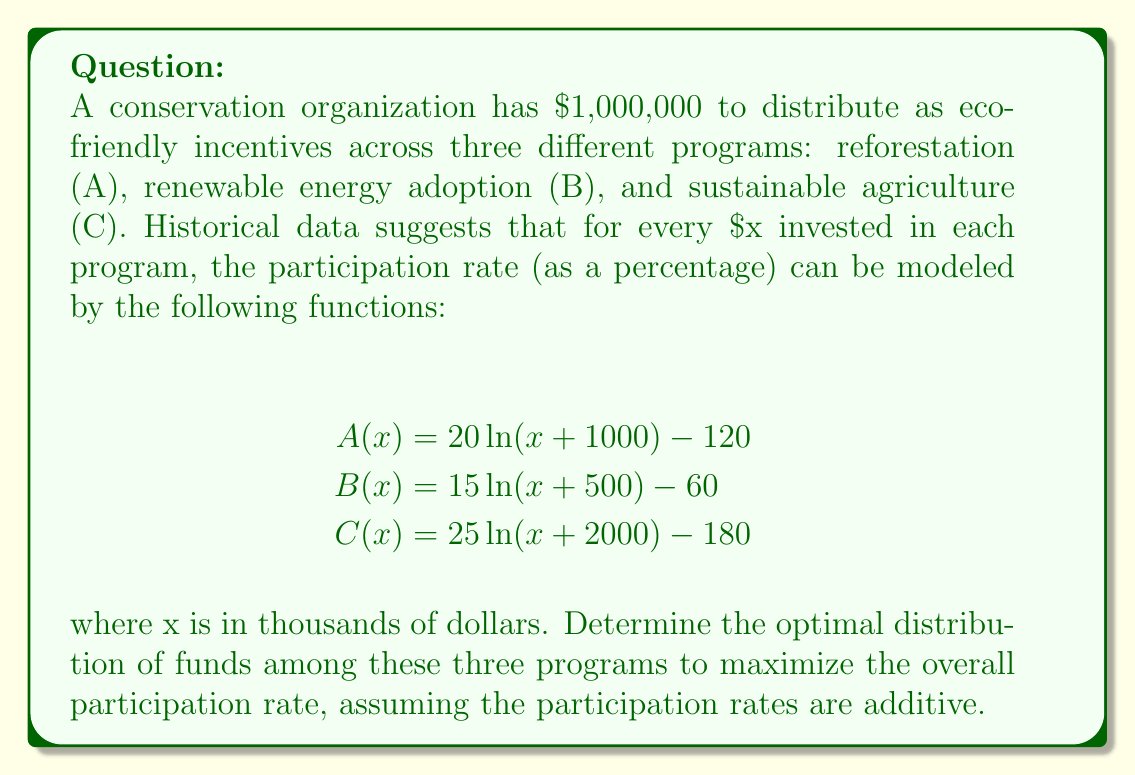What is the answer to this math problem? To solve this optimization problem, we'll use the method of Lagrange multipliers:

1) Let's define our objective function as the sum of the participation rates:
   $$f(x,y,z) = [20\ln(x+1) - 120] + [15\ln(y+0.5) - 60] + [25\ln(z+2) - 180]$$
   where x, y, and z are in millions of dollars for programs A, B, and C respectively.

2) Our constraint is:
   $$g(x,y,z) = x + y + z - 1 = 0$$

3) We form the Lagrangian:
   $$L(x,y,z,\lambda) = f(x,y,z) - \lambda g(x,y,z)$$

4) We set the partial derivatives equal to zero:
   $$\frac{\partial L}{\partial x} = \frac{20}{x+1} - \lambda = 0$$
   $$\frac{\partial L}{\partial y} = \frac{15}{y+0.5} - \lambda = 0$$
   $$\frac{\partial L}{\partial z} = \frac{25}{z+2} - \lambda = 0$$
   $$\frac{\partial L}{\partial \lambda} = x + y + z - 1 = 0$$

5) From the first three equations:
   $$\frac{20}{x+1} = \frac{15}{y+0.5} = \frac{25}{z+2} = \lambda$$

6) This implies:
   $$\frac{x+1}{20} = \frac{y+0.5}{15} = \frac{z+2}{25}$$

7) Let's call this common ratio k. Then:
   $$x = 20k - 1$$
   $$y = 15k - 0.5$$
   $$z = 25k - 2$$

8) Substituting these into our constraint equation:
   $$(20k - 1) + (15k - 0.5) + (25k - 2) = 1$$
   $$60k - 3.5 = 1$$
   $$60k = 4.5$$
   $$k = 0.075$$

9) Now we can solve for x, y, and z:
   $$x = 20(0.075) - 1 = 0.5$$
   $$y = 15(0.075) - 0.5 = 0.625$$
   $$z = 25(0.075) - 2 = -0.125$$

10) However, z cannot be negative. This means we need to adjust our solution. The closest feasible solution is to set z = 0 and redistribute the remaining funds between x and y.

11) We repeat steps 5-9 with only x and y, and the new constraint x + y = 1:
    $$\frac{x+1}{20} = \frac{y+0.5}{15} = k$$
    $$x = 20k - 1$$
    $$y = 15k - 0.5$$
    $$(20k - 1) + (15k - 0.5) = 1$$
    $$35k = 2.5$$
    $$k = \frac{5}{70} = \frac{1}{14}$$

12) Finally, we can calculate x and y:
    $$x = 20(\frac{1}{14}) - 1 = \frac{10}{7} - 1 = \frac{3}{7} \approx 0.429$$
    $$y = 15(\frac{1}{14}) - 0.5 = \frac{15}{14} - \frac{7}{14} = \frac{4}{7} \approx 0.571$$
    $$z = 0$$
Answer: The optimal distribution of funds is approximately:
Program A (reforestation): $429,000
Program B (renewable energy adoption): $571,000
Program C (sustainable agriculture): $0 